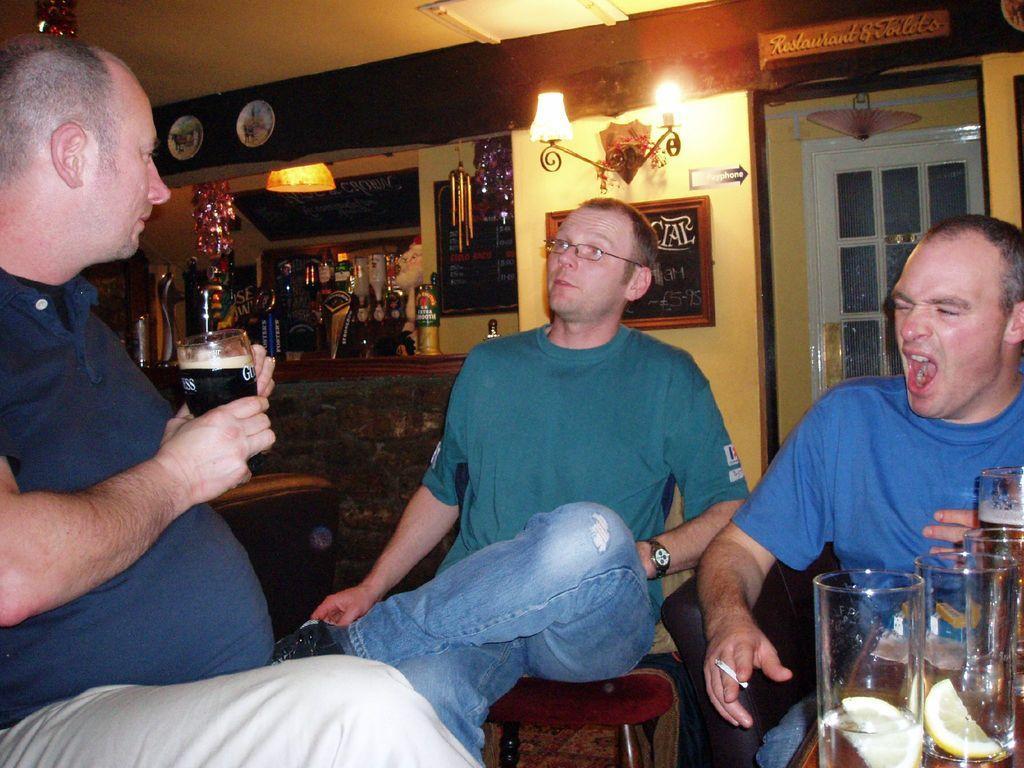In one or two sentences, can you explain what this image depicts? in this image the three persons are sitting on the chair and behind the person metals and some lights are there the three person are wearing the t-shirt and jeans pant and the back ground is very dark 